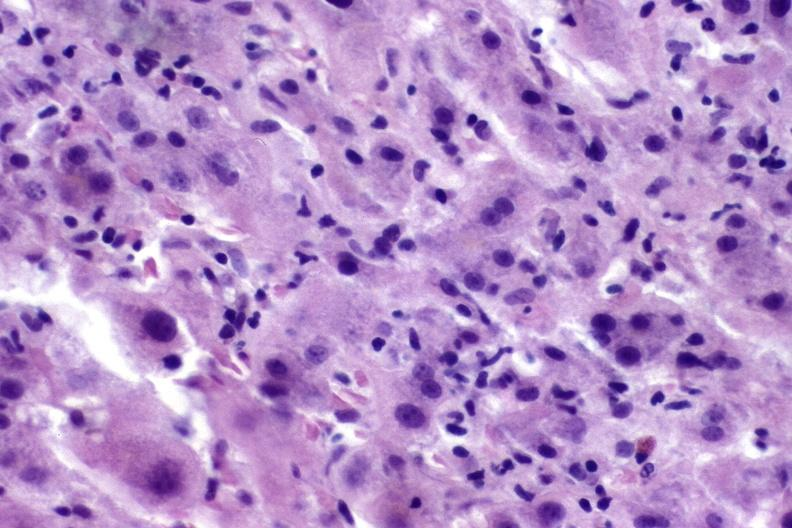does this image show autoimmune hepatitis?
Answer the question using a single word or phrase. Yes 